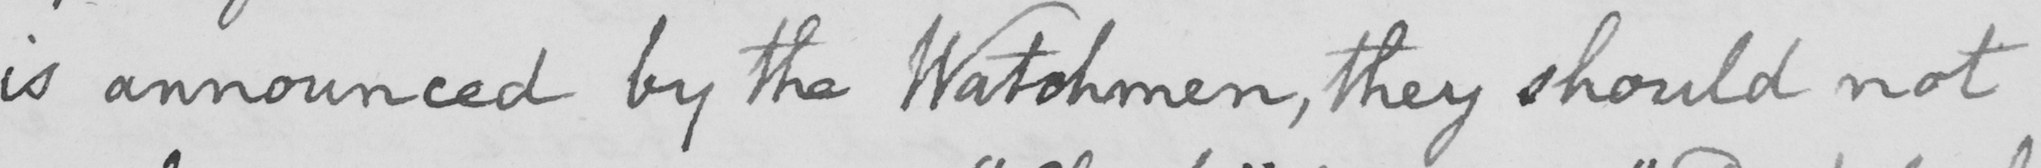Please provide the text content of this handwritten line. is announced by the Watchmen , they should not 